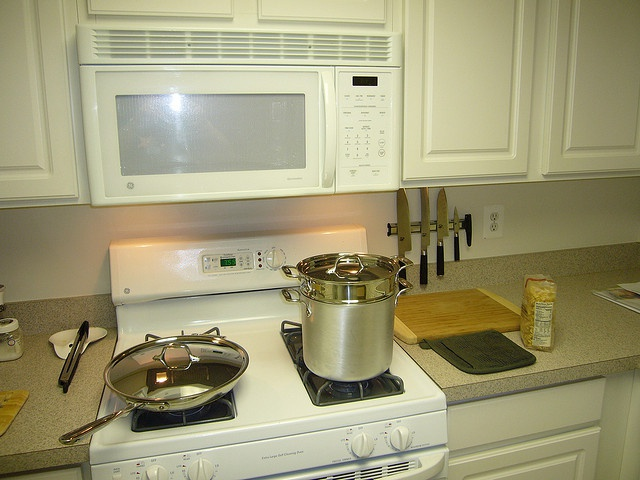Describe the objects in this image and their specific colors. I can see oven in olive, beige, darkgray, and black tones, microwave in olive, darkgray, beige, and tan tones, knife in olive, black, and gray tones, knife in olive and black tones, and knife in olive and black tones in this image. 